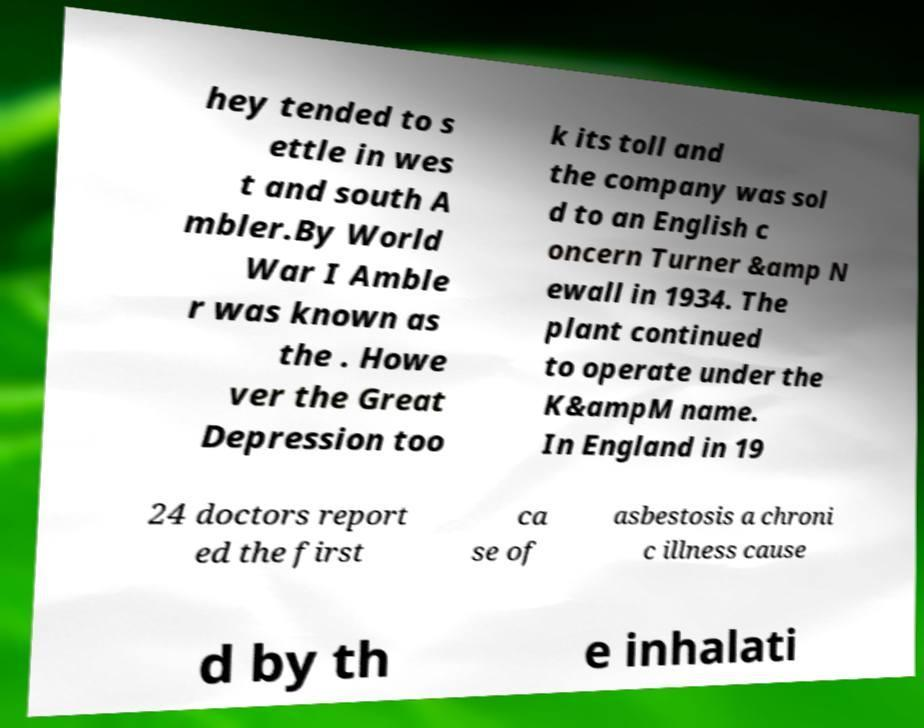I need the written content from this picture converted into text. Can you do that? hey tended to s ettle in wes t and south A mbler.By World War I Amble r was known as the . Howe ver the Great Depression too k its toll and the company was sol d to an English c oncern Turner &amp N ewall in 1934. The plant continued to operate under the K&ampM name. In England in 19 24 doctors report ed the first ca se of asbestosis a chroni c illness cause d by th e inhalati 